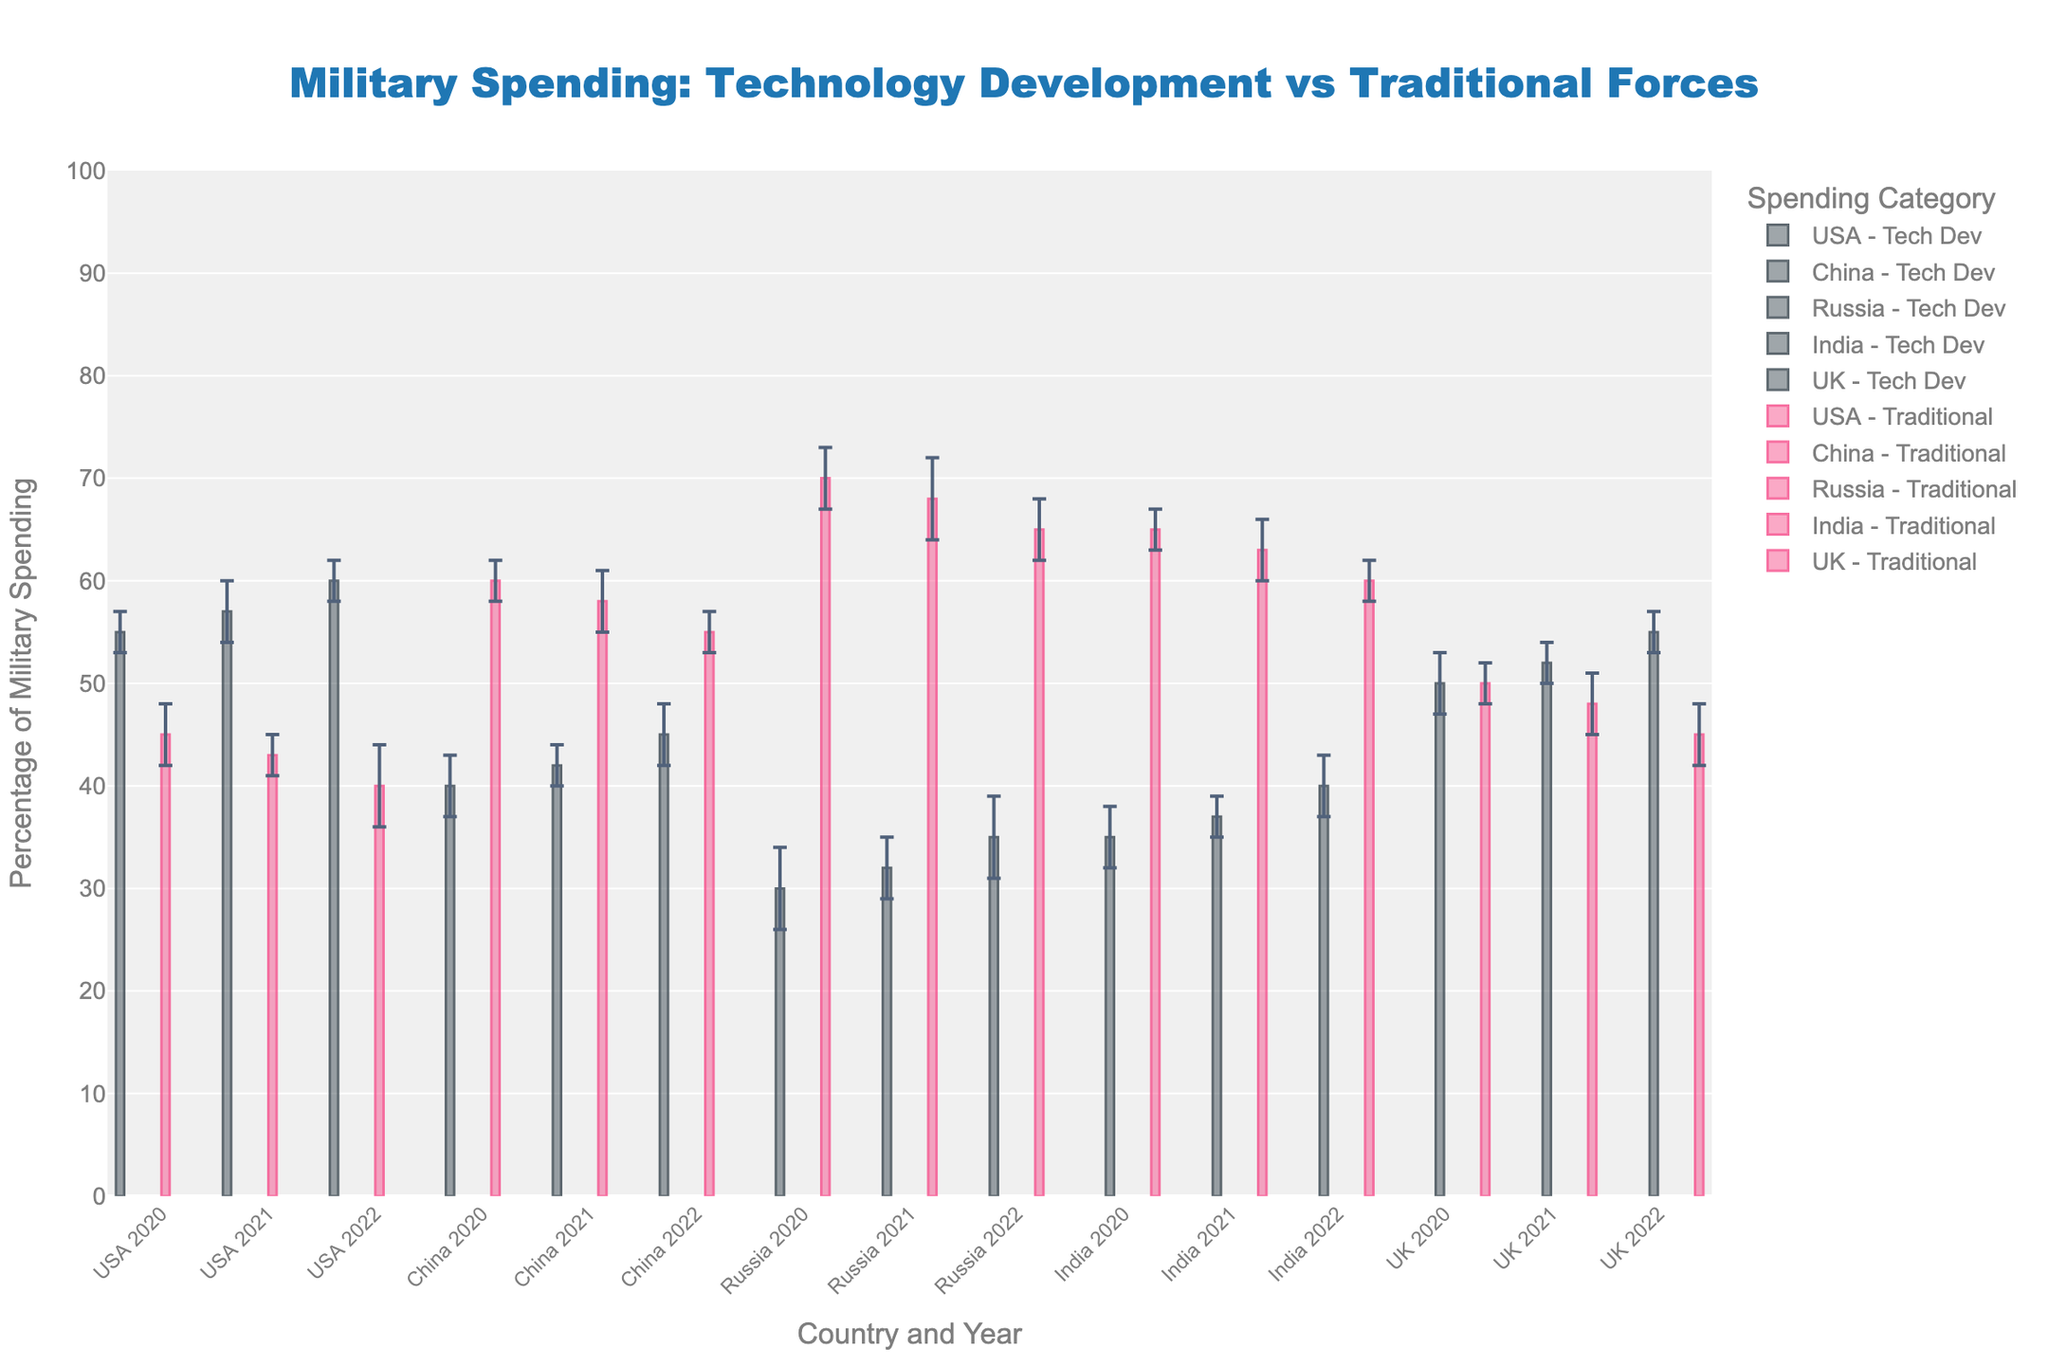What's the overall trend of technology development spending by the USA from 2020 to 2022? By looking at the figure, we see that the percentage of spending on technology development by the USA increases from 55% in 2020 to 60% in 2022. This indicates a rising investment in technology over the years.
Answer: Increasing Which country has the highest allocation to traditional forces in 2022? In the 2022 data points, Russia has the highest allocation to traditional forces at 65%. This can be observed directly from the figure where Russia's bar is the tallest among the traditional forces category.
Answer: Russia What is the difference between the technology development spending and traditional forces spending for India in 2021? For India in 2021, the technology development spending is 37% and the traditional forces spending is 63%. The difference is calculated as 63% - 37% = 26%.
Answer: 26% How does the UK's technology development spending in 2022 compare to that of China in the same year? According to the figure, the UK's technology development spending in 2022 is 55% while China's is 45%. This shows that the UK's allocation is 10 percentage points higher than China's.
Answer: 10% higher Which country shows the least variability in technology development spending from 2020 to 2022 based on the error margins? The USA shows the least variability in technology development spending, as seen by the small error margins (ranging from 2% to 3%) compared to other countries like Russia, which has error margins of up to 4%.
Answer: USA What is the average percentage of traditional forces spending for all countries in 2021? To find the average percentage, add the traditional forces percentages for 2021 (USA: 43%, China: 58%, Russia: 68%, India: 63%, UK: 48%) and divide by 5. (43 + 58 + 68 + 63 + 48) / 5 = 56%.
Answer: 56% Which country had a notable shift towards traditional forces from 2020 to 2022? Russia shows a significant shift towards traditional forces from 70% in 2020 to 65% in 2022. This is a noticeable but modest decrease indicating a gradual shift.
Answer: Russia For the year 2020, which country has the smallest proportion of its military budget spent on technology development? In 2020, Russia has the smallest proportion of its military budget spent on technology development, at 30%. This can be observed from the shortest bar in the technology development category for that year.
Answer: Russia 